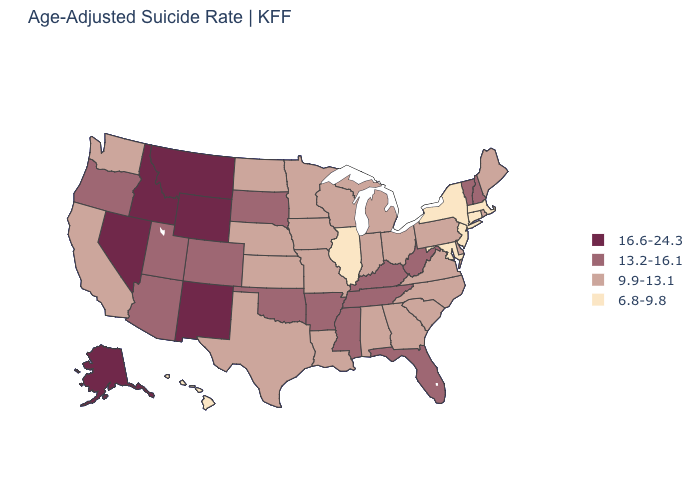Is the legend a continuous bar?
Keep it brief. No. What is the highest value in the USA?
Be succinct. 16.6-24.3. Is the legend a continuous bar?
Be succinct. No. How many symbols are there in the legend?
Write a very short answer. 4. Name the states that have a value in the range 6.8-9.8?
Write a very short answer. Connecticut, Hawaii, Illinois, Maryland, Massachusetts, New Jersey, New York. Does Connecticut have the lowest value in the USA?
Quick response, please. Yes. Name the states that have a value in the range 6.8-9.8?
Answer briefly. Connecticut, Hawaii, Illinois, Maryland, Massachusetts, New Jersey, New York. Does Michigan have the lowest value in the MidWest?
Write a very short answer. No. What is the lowest value in states that border Oklahoma?
Short answer required. 9.9-13.1. What is the value of Maine?
Give a very brief answer. 9.9-13.1. What is the value of Indiana?
Give a very brief answer. 9.9-13.1. What is the highest value in states that border Colorado?
Be succinct. 16.6-24.3. Name the states that have a value in the range 6.8-9.8?
Write a very short answer. Connecticut, Hawaii, Illinois, Maryland, Massachusetts, New Jersey, New York. Does the map have missing data?
Quick response, please. No. Name the states that have a value in the range 9.9-13.1?
Be succinct. Alabama, California, Delaware, Georgia, Indiana, Iowa, Kansas, Louisiana, Maine, Michigan, Minnesota, Missouri, Nebraska, North Carolina, North Dakota, Ohio, Pennsylvania, Rhode Island, South Carolina, Texas, Virginia, Washington, Wisconsin. 